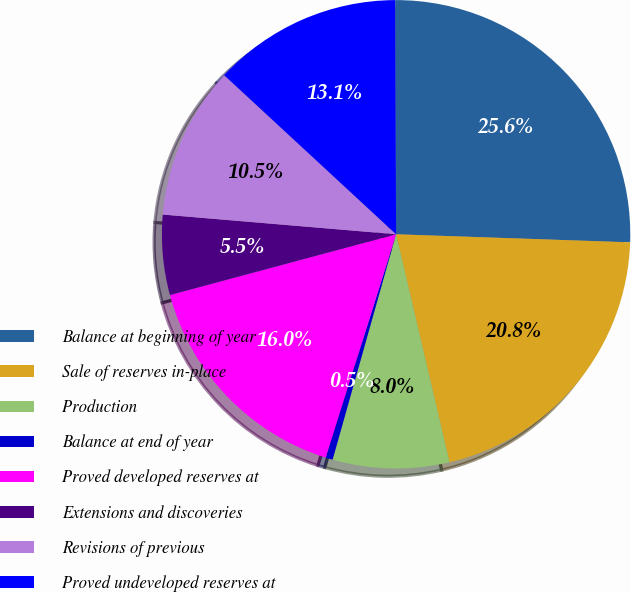<chart> <loc_0><loc_0><loc_500><loc_500><pie_chart><fcel>Balance at beginning of year<fcel>Sale of reserves in-place<fcel>Production<fcel>Balance at end of year<fcel>Proved developed reserves at<fcel>Extensions and discoveries<fcel>Revisions of previous<fcel>Proved undeveloped reserves at<nl><fcel>25.61%<fcel>20.79%<fcel>8.03%<fcel>0.49%<fcel>15.96%<fcel>5.52%<fcel>10.54%<fcel>13.05%<nl></chart> 